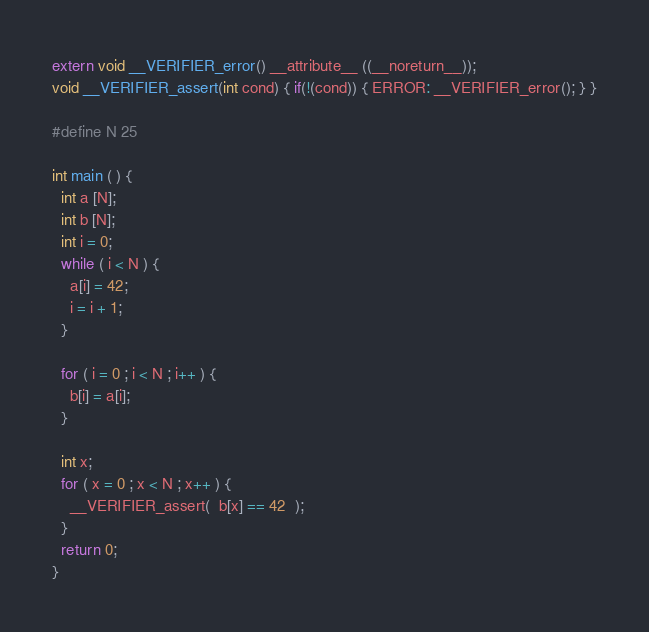<code> <loc_0><loc_0><loc_500><loc_500><_C_>extern void __VERIFIER_error() __attribute__ ((__noreturn__));
void __VERIFIER_assert(int cond) { if(!(cond)) { ERROR: __VERIFIER_error(); } }

#define N 25

int main ( ) {
  int a [N];
  int b [N]; 
  int i = 0;
  while ( i < N ) {
    a[i] = 42;
    i = i + 1;
  }

  for ( i = 0 ; i < N ; i++ ) {
    b[i] = a[i];
  }
  
  int x;
  for ( x = 0 ; x < N ; x++ ) {
    __VERIFIER_assert(  b[x] == 42  );
  }
  return 0;
}
</code> 